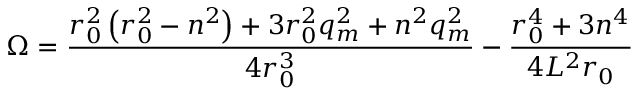<formula> <loc_0><loc_0><loc_500><loc_500>\Omega = \frac { r _ { 0 } ^ { 2 } \left ( r _ { 0 } ^ { 2 } - n ^ { 2 } \right ) + 3 r _ { 0 } ^ { 2 } q _ { m } ^ { 2 } + n ^ { 2 } q _ { m } ^ { 2 } } { 4 r _ { 0 } ^ { 3 } } - \frac { r _ { 0 } ^ { 4 } + 3 n ^ { 4 } } { 4 L ^ { 2 } r _ { 0 } }</formula> 